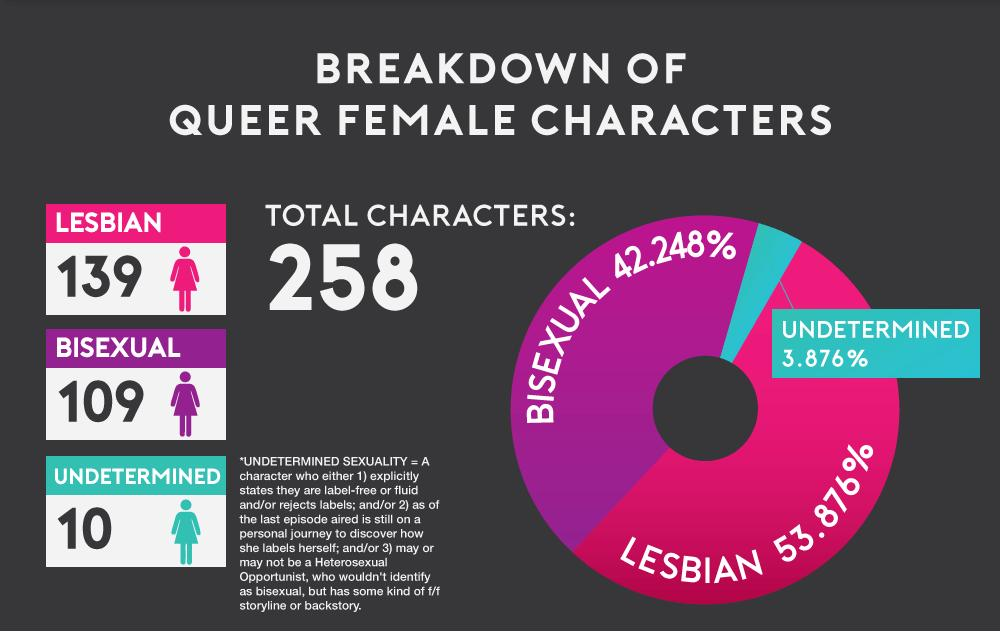Outline some significant characteristics in this image. The color that represents "Lesbian" in the pie chart is pink. There are 119 Queer female characters in the infographic, excluding those who are solely identified as lesbian. The color that represents "Undetermined" in the pie chart is blue. According to the data provided, 96.124% of the queer female characters on television are lesbian or bisexual. 